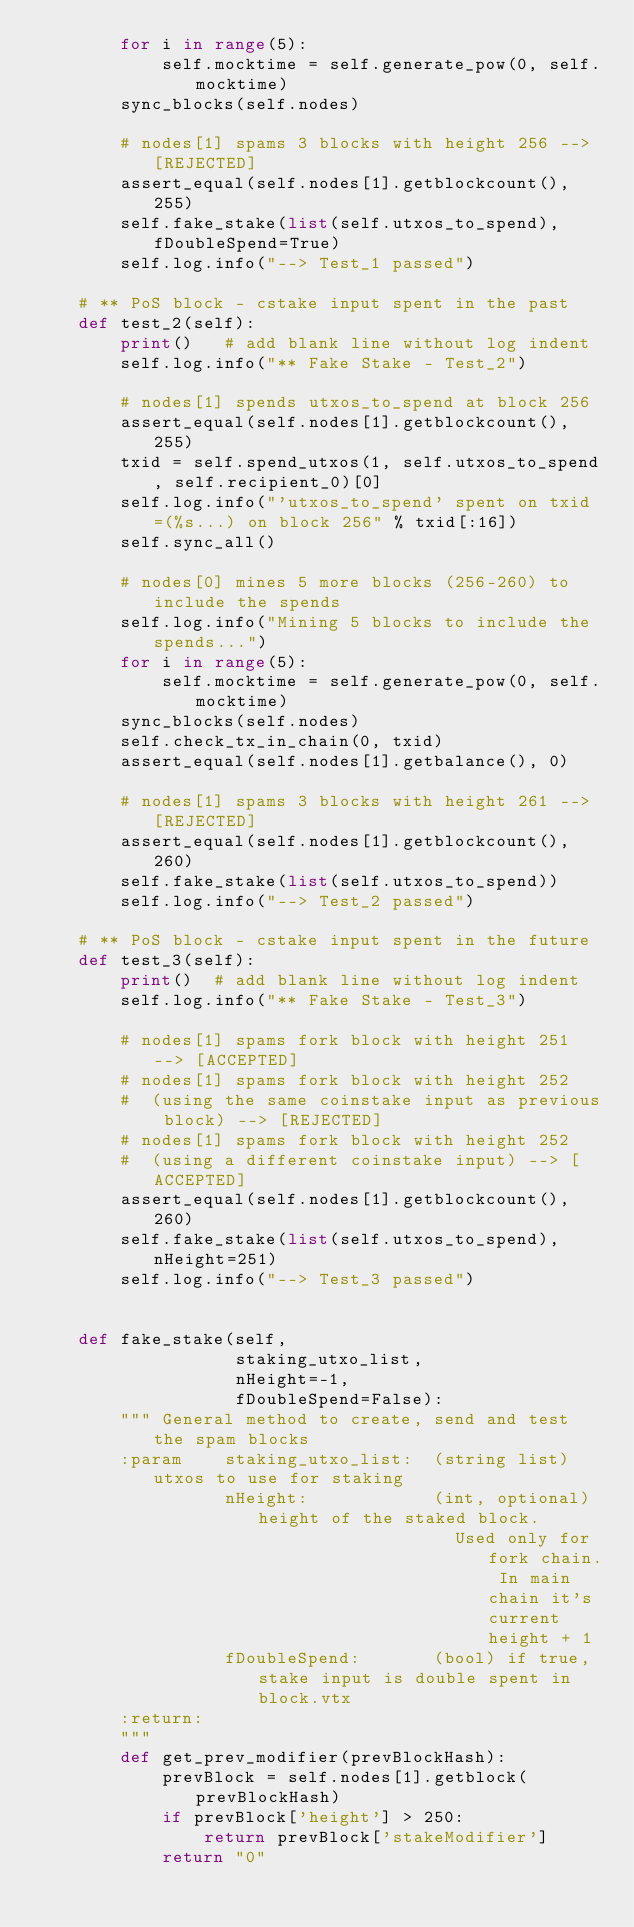Convert code to text. <code><loc_0><loc_0><loc_500><loc_500><_Python_>        for i in range(5):
            self.mocktime = self.generate_pow(0, self.mocktime)
        sync_blocks(self.nodes)

        # nodes[1] spams 3 blocks with height 256 --> [REJECTED]
        assert_equal(self.nodes[1].getblockcount(), 255)
        self.fake_stake(list(self.utxos_to_spend), fDoubleSpend=True)
        self.log.info("--> Test_1 passed")

    # ** PoS block - cstake input spent in the past
    def test_2(self):
        print()   # add blank line without log indent
        self.log.info("** Fake Stake - Test_2")

        # nodes[1] spends utxos_to_spend at block 256
        assert_equal(self.nodes[1].getblockcount(), 255)
        txid = self.spend_utxos(1, self.utxos_to_spend, self.recipient_0)[0]
        self.log.info("'utxos_to_spend' spent on txid=(%s...) on block 256" % txid[:16])
        self.sync_all()

        # nodes[0] mines 5 more blocks (256-260) to include the spends
        self.log.info("Mining 5 blocks to include the spends...")
        for i in range(5):
            self.mocktime = self.generate_pow(0, self.mocktime)
        sync_blocks(self.nodes)
        self.check_tx_in_chain(0, txid)
        assert_equal(self.nodes[1].getbalance(), 0)

        # nodes[1] spams 3 blocks with height 261 --> [REJECTED]
        assert_equal(self.nodes[1].getblockcount(), 260)
        self.fake_stake(list(self.utxos_to_spend))
        self.log.info("--> Test_2 passed")

    # ** PoS block - cstake input spent in the future
    def test_3(self):
        print()  # add blank line without log indent
        self.log.info("** Fake Stake - Test_3")

        # nodes[1] spams fork block with height 251 --> [ACCEPTED]
        # nodes[1] spams fork block with height 252
        #  (using the same coinstake input as previous block) --> [REJECTED]
        # nodes[1] spams fork block with height 252
        #  (using a different coinstake input) --> [ACCEPTED]
        assert_equal(self.nodes[1].getblockcount(), 260)
        self.fake_stake(list(self.utxos_to_spend), nHeight=251)
        self.log.info("--> Test_3 passed")


    def fake_stake(self,
                   staking_utxo_list,
                   nHeight=-1,
                   fDoubleSpend=False):
        """ General method to create, send and test the spam blocks
        :param    staking_utxo_list:  (string list) utxos to use for staking
                  nHeight:            (int, optional) height of the staked block.
                                        Used only for fork chain. In main chain it's current height + 1
                  fDoubleSpend:       (bool) if true, stake input is double spent in block.vtx
        :return:
        """
        def get_prev_modifier(prevBlockHash):
            prevBlock = self.nodes[1].getblock(prevBlockHash)
            if prevBlock['height'] > 250:
                return prevBlock['stakeModifier']
            return "0"
</code> 